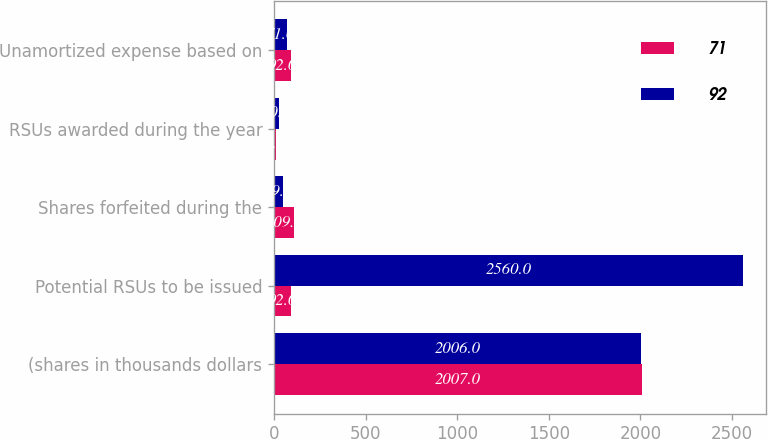Convert chart. <chart><loc_0><loc_0><loc_500><loc_500><stacked_bar_chart><ecel><fcel>(shares in thousands dollars<fcel>Potential RSUs to be issued<fcel>Shares forfeited during the<fcel>RSUs awarded during the year<fcel>Unamortized expense based on<nl><fcel>71<fcel>2007<fcel>92<fcel>109<fcel>9<fcel>92<nl><fcel>92<fcel>2006<fcel>2560<fcel>49<fcel>30<fcel>71<nl></chart> 